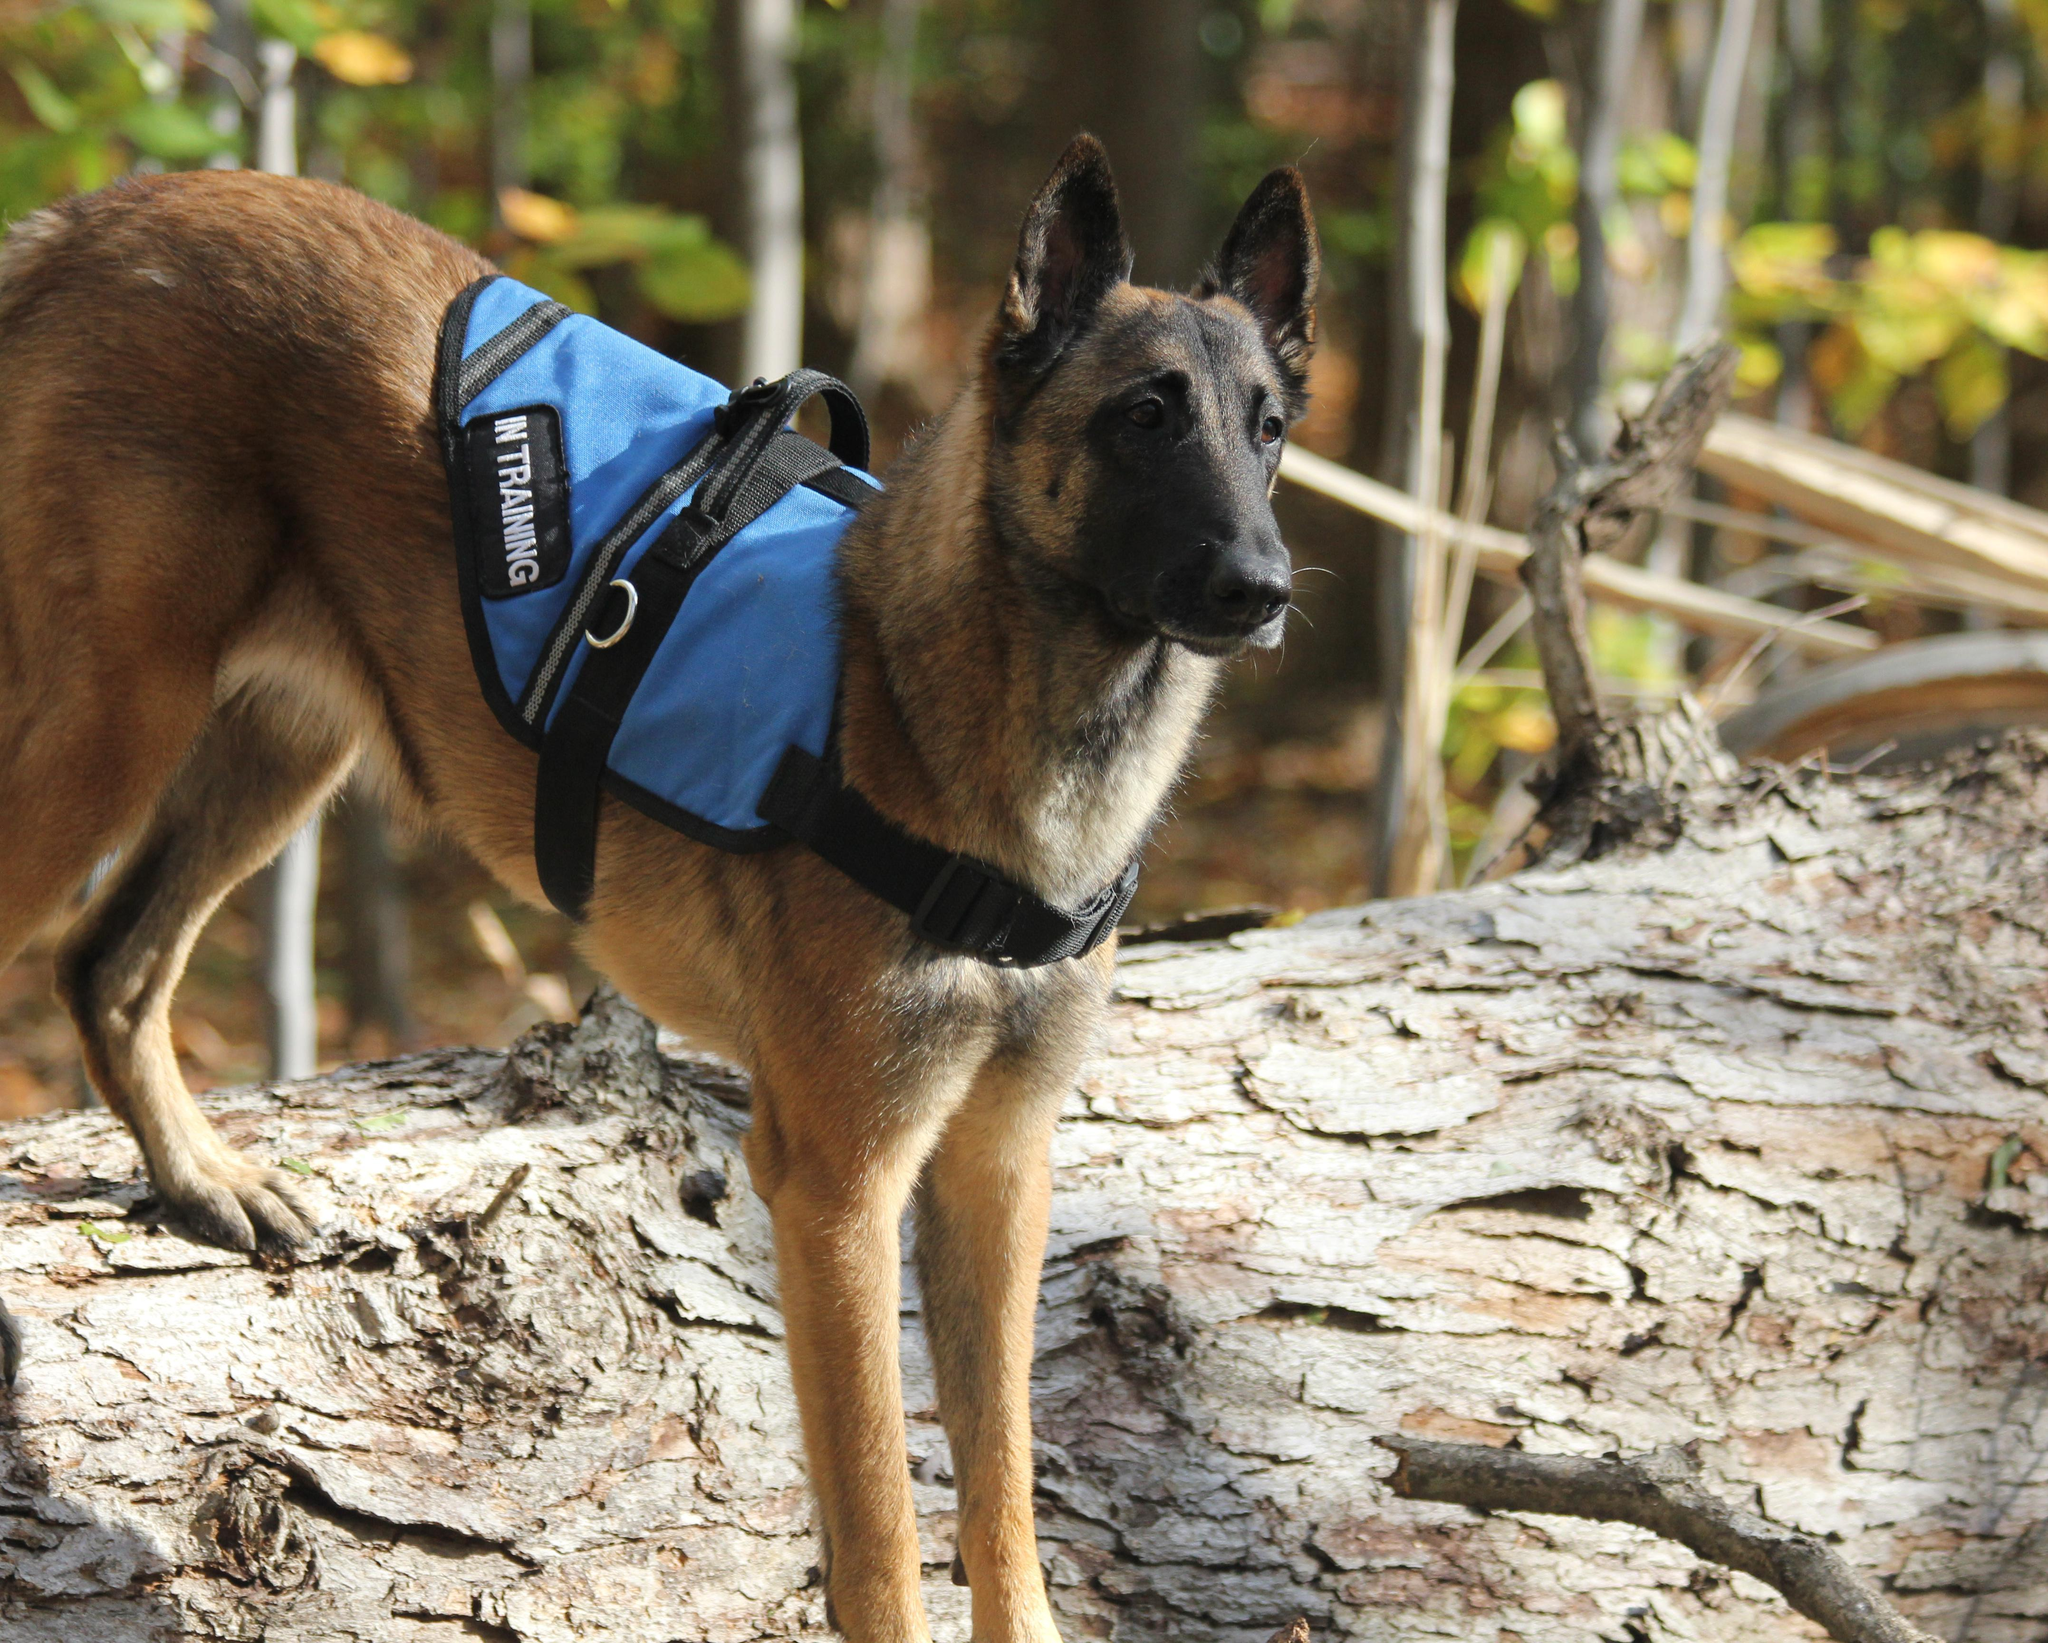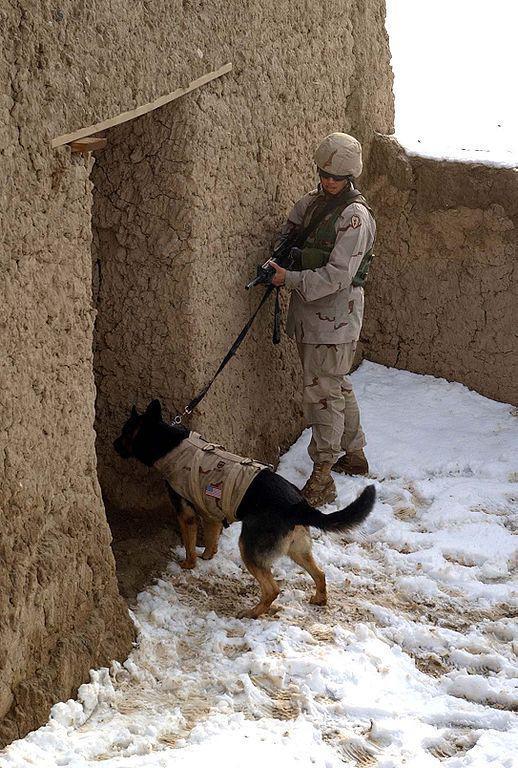The first image is the image on the left, the second image is the image on the right. Examine the images to the left and right. Is the description "A dog is shown with only one soldier in one image" accurate? Answer yes or no. Yes. The first image is the image on the left, the second image is the image on the right. Considering the images on both sides, is "One of the images shows a dog completely in the air." valid? Answer yes or no. No. 